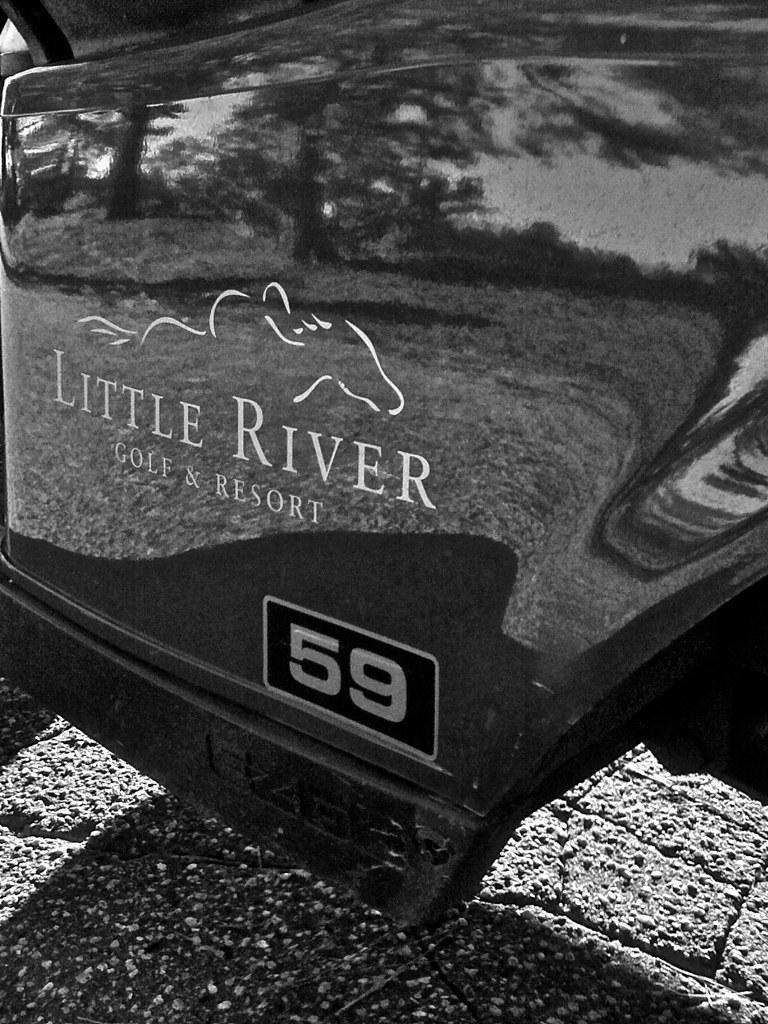In one or two sentences, can you explain what this image depicts? Here in this picture we can see a door of a vehicle and on that we can see some text and a picture present. 